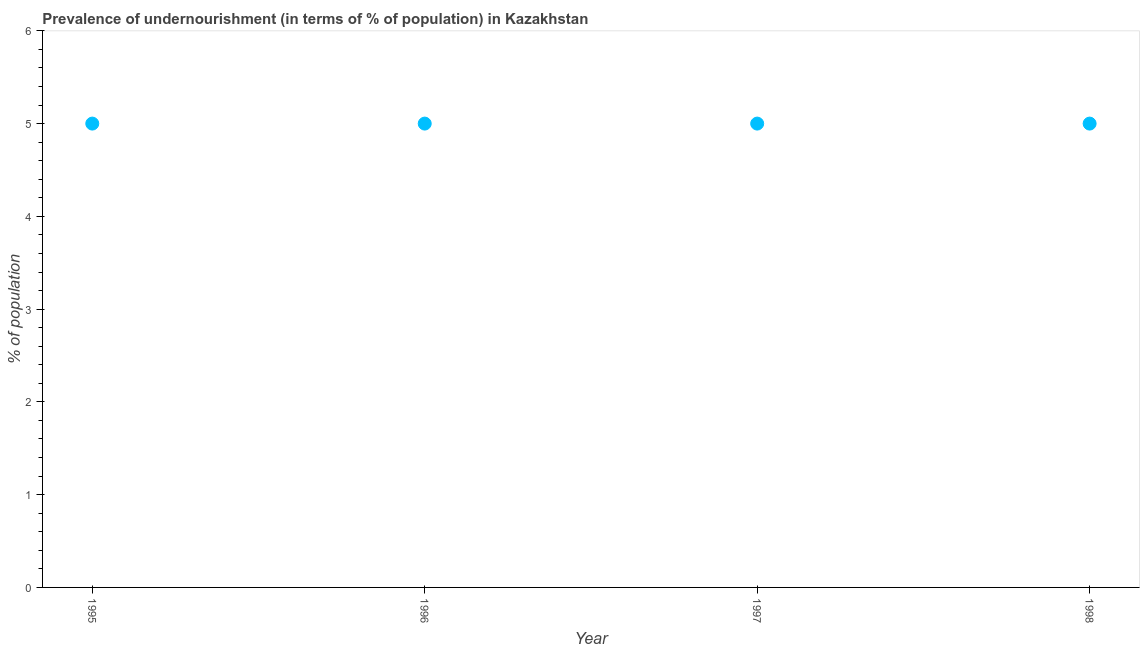Across all years, what is the maximum percentage of undernourished population?
Your response must be concise. 5. In which year was the percentage of undernourished population maximum?
Make the answer very short. 1995. In which year was the percentage of undernourished population minimum?
Your response must be concise. 1995. What is the difference between the percentage of undernourished population in 1997 and 1998?
Offer a terse response. 0. What is the median percentage of undernourished population?
Ensure brevity in your answer.  5. In how many years, is the percentage of undernourished population greater than 2.2 %?
Your answer should be compact. 4. Is the percentage of undernourished population in 1995 less than that in 1997?
Provide a succinct answer. No. What is the difference between the highest and the second highest percentage of undernourished population?
Keep it short and to the point. 0. Is the sum of the percentage of undernourished population in 1995 and 1997 greater than the maximum percentage of undernourished population across all years?
Make the answer very short. Yes. In how many years, is the percentage of undernourished population greater than the average percentage of undernourished population taken over all years?
Keep it short and to the point. 0. Does the percentage of undernourished population monotonically increase over the years?
Offer a very short reply. No. How many years are there in the graph?
Provide a succinct answer. 4. Does the graph contain any zero values?
Ensure brevity in your answer.  No. What is the title of the graph?
Give a very brief answer. Prevalence of undernourishment (in terms of % of population) in Kazakhstan. What is the label or title of the X-axis?
Your answer should be compact. Year. What is the label or title of the Y-axis?
Offer a terse response. % of population. What is the % of population in 1995?
Keep it short and to the point. 5. What is the % of population in 1998?
Your answer should be compact. 5. What is the difference between the % of population in 1995 and 1996?
Your answer should be compact. 0. What is the difference between the % of population in 1995 and 1998?
Provide a succinct answer. 0. What is the difference between the % of population in 1996 and 1998?
Your response must be concise. 0. What is the ratio of the % of population in 1995 to that in 1996?
Your answer should be very brief. 1. What is the ratio of the % of population in 1995 to that in 1997?
Your response must be concise. 1. What is the ratio of the % of population in 1997 to that in 1998?
Your answer should be very brief. 1. 